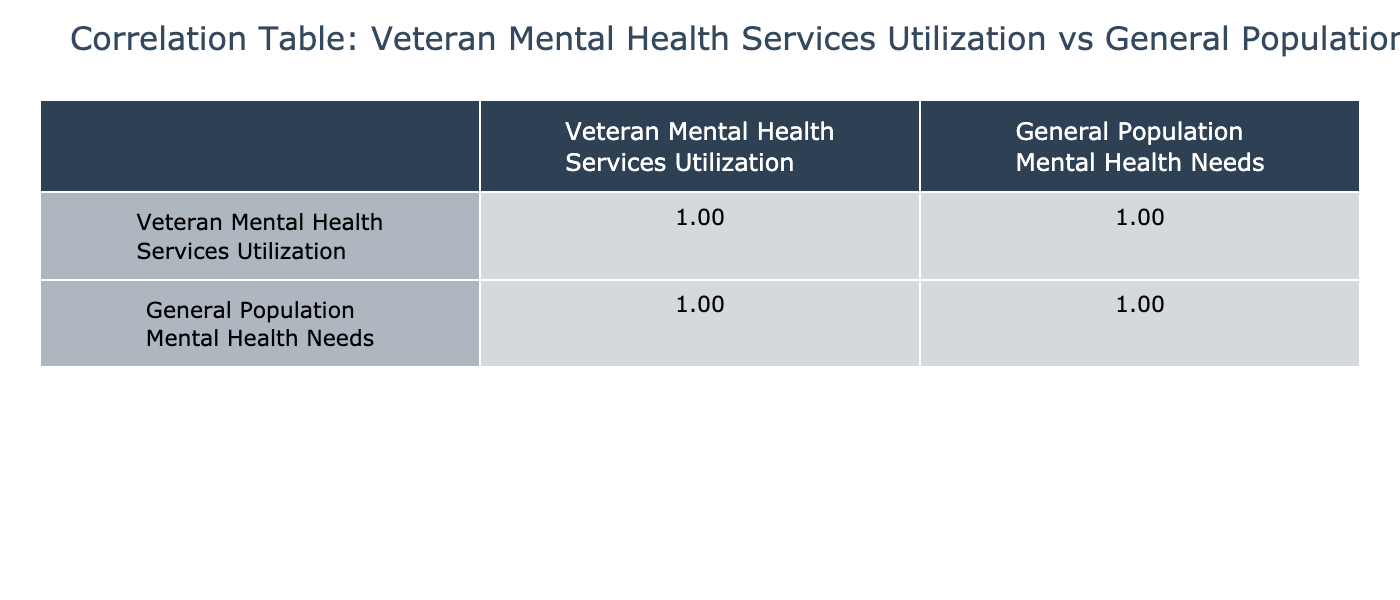What was the veteran mental health services utilization in 2020? In the table, we can find the data for 2020 in the first column under the row labeled '2020'. The value for that year is 4500.
Answer: 4500 What was the general population mental health needs in 2019? By referencing the table, the value for the general population mental health needs in 2019 is listed in the second column under the row labeled '2019', which is 25000.
Answer: 25000 What is the increase in veteran mental health services utilization from 2018 to 2023? We take the value for veteran mental health services utilization in 2023, which is 6000, and subtract the value for 2018, which is 3500. Thus, the increase is 6000 - 3500 = 2500.
Answer: 2500 What is the average general population mental health needs from 2018 to 2023? To find the average, we add all the values from 2018 (22000), 2019 (25000), 2020 (27000), 2021 (30000), 2022 (32000), and 2023 (34000), giving us a total of 22000 + 25000 + 27000 + 30000 + 32000 + 34000 = 171000. Now we divide by the number of years, which is 6. Therefore, the average is 171000 / 6 = 28500.
Answer: 28500 Is the correlation between veteran mental health services utilization and general population mental health needs positive? The correlation values can be assessed in the table. A value greater than 0 under the correlation label between these two variables indicates a positive correlation. If we check the values, we confirm they are both positive, indicating a positive correlation.
Answer: Yes Did veteran mental health services utilization grow faster than general population mental health needs over the years? To answer this, we compare the growth rates over the period. Veteran mental health services utilization increased from 3500 in 2018 to 6000 in 2023 (an increase of 2500), while general population mental health needs grew from 22000 to 34000 (an increase of 12000). The percentage growth for veterans is (2500/3500)*100 = 71.43%, and for the general population, it's (12000/22000)*100 = 54.55%. Since 71.43% is greater than 54.55%, we conclude that veteran utilization grew faster.
Answer: Yes 